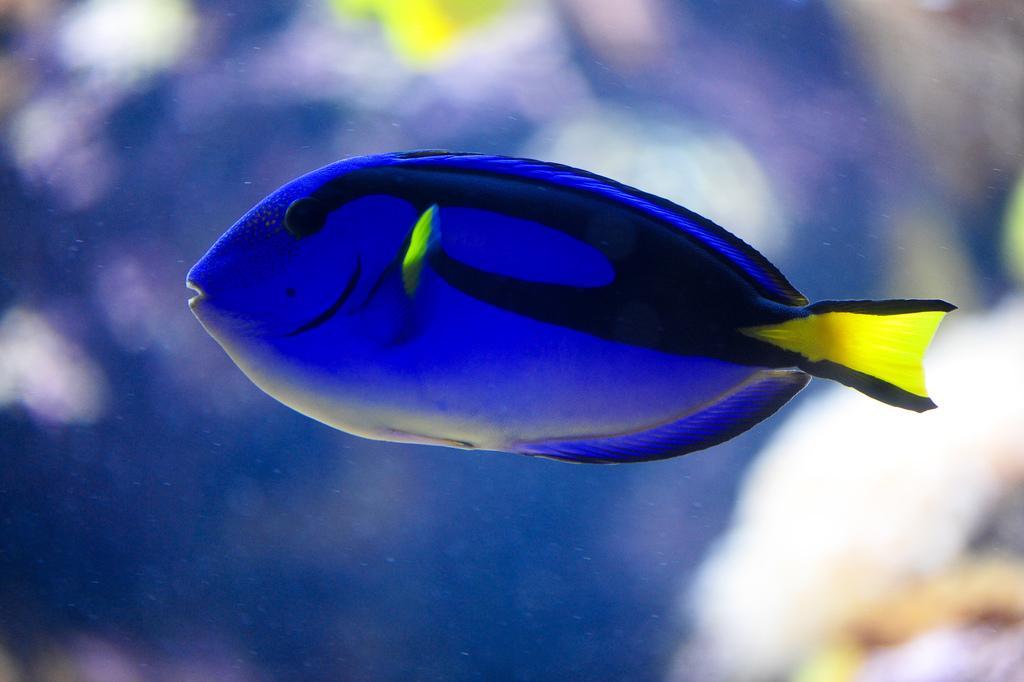How would you summarize this image in a sentence or two? In this image we can see a fish in the water. 